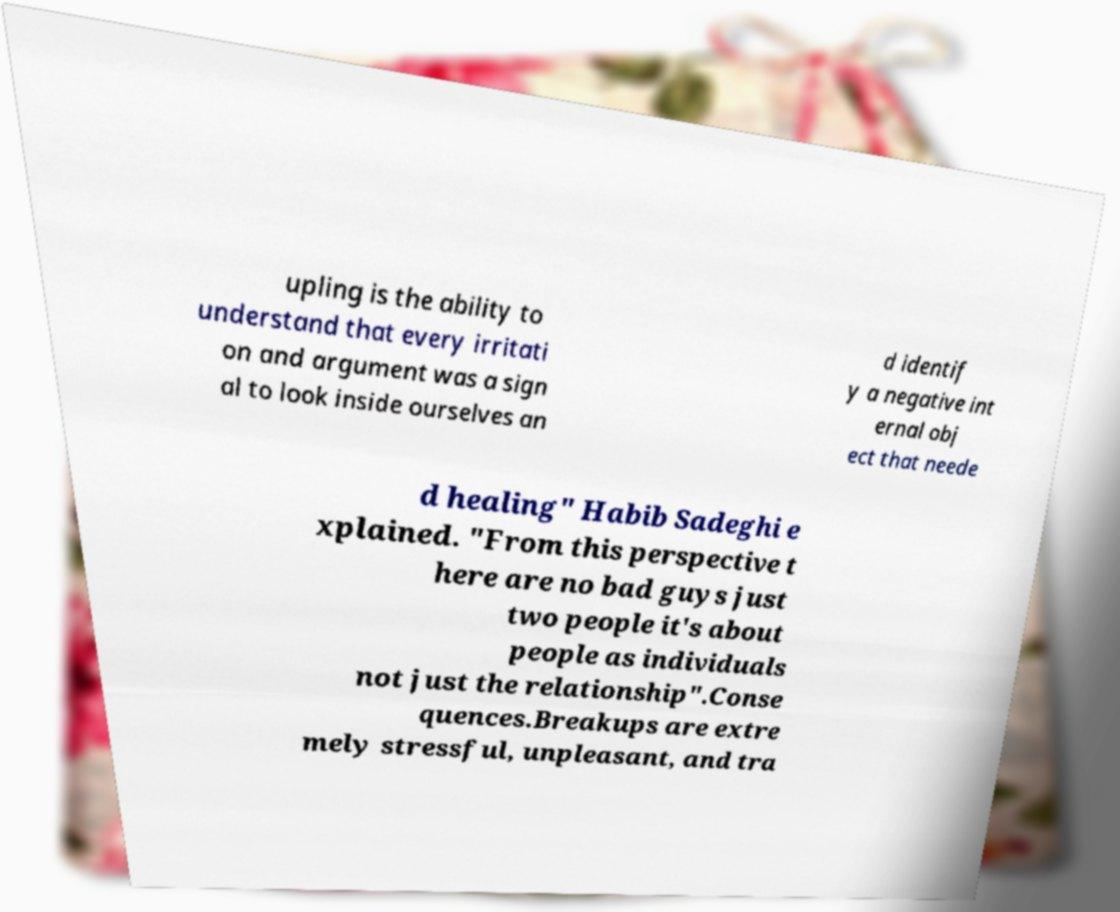Can you accurately transcribe the text from the provided image for me? upling is the ability to understand that every irritati on and argument was a sign al to look inside ourselves an d identif y a negative int ernal obj ect that neede d healing" Habib Sadeghi e xplained. "From this perspective t here are no bad guys just two people it's about people as individuals not just the relationship".Conse quences.Breakups are extre mely stressful, unpleasant, and tra 